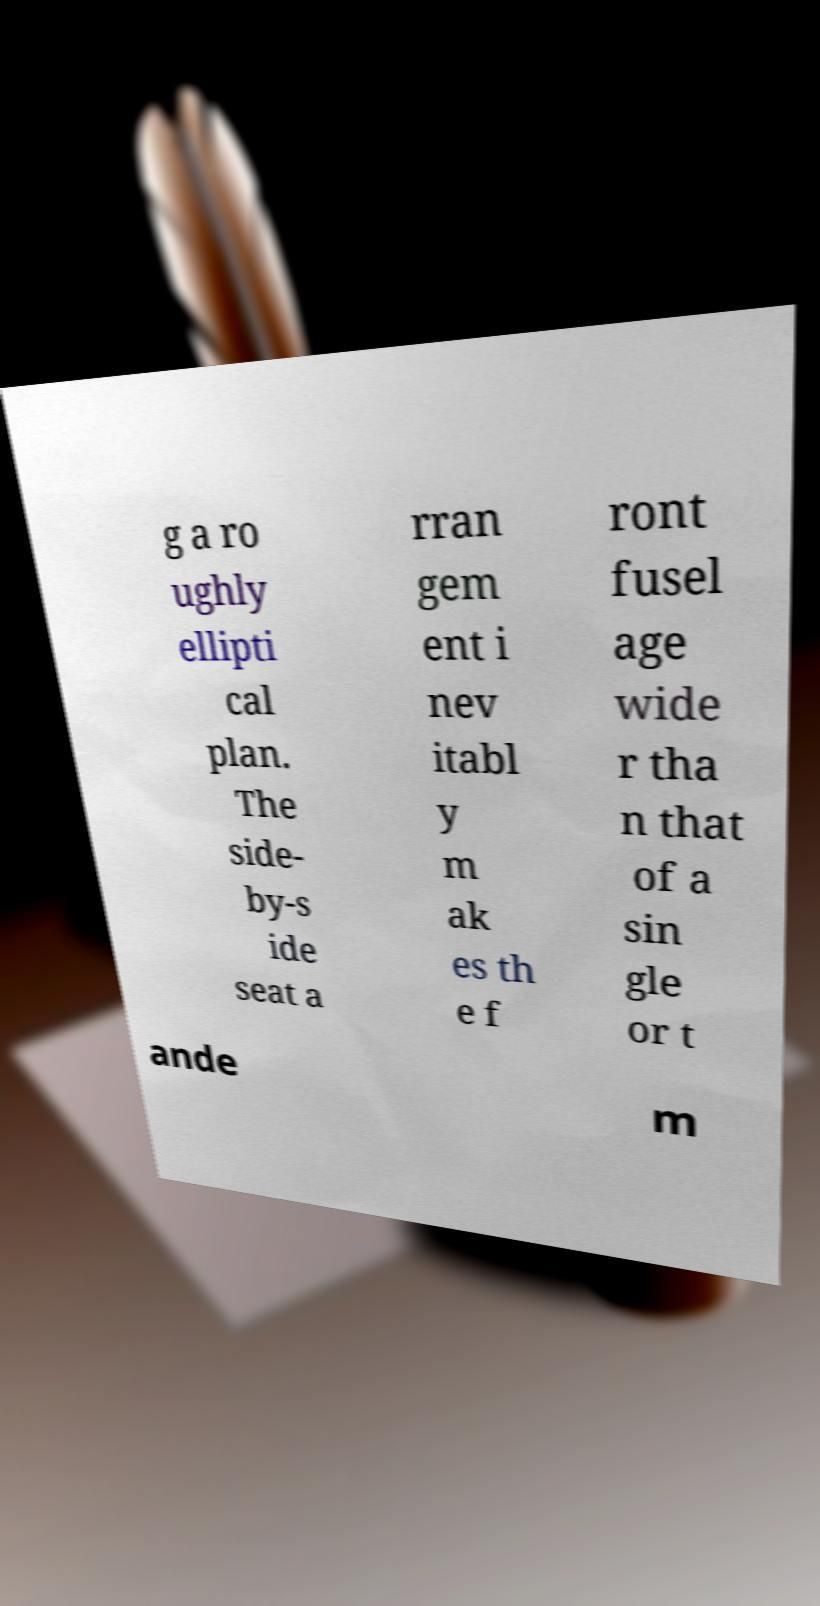Can you accurately transcribe the text from the provided image for me? g a ro ughly ellipti cal plan. The side- by-s ide seat a rran gem ent i nev itabl y m ak es th e f ront fusel age wide r tha n that of a sin gle or t ande m 